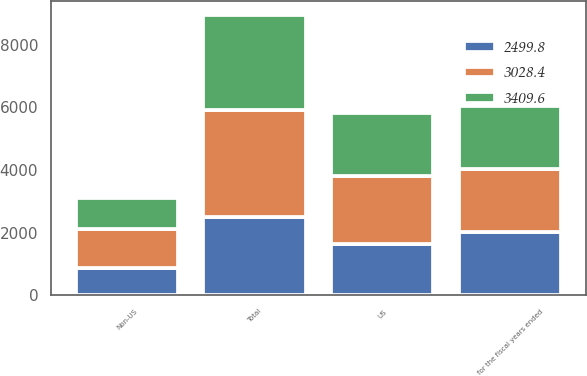Convert chart to OTSL. <chart><loc_0><loc_0><loc_500><loc_500><stacked_bar_chart><ecel><fcel>for the fiscal years ended<fcel>US<fcel>Non-US<fcel>Total<nl><fcel>2499.8<fcel>2016<fcel>1641.7<fcel>858.1<fcel>2499.8<nl><fcel>3409.6<fcel>2015<fcel>2026.4<fcel>1002<fcel>3028.4<nl><fcel>3028.4<fcel>2014<fcel>2160.8<fcel>1248.8<fcel>3409.6<nl></chart> 